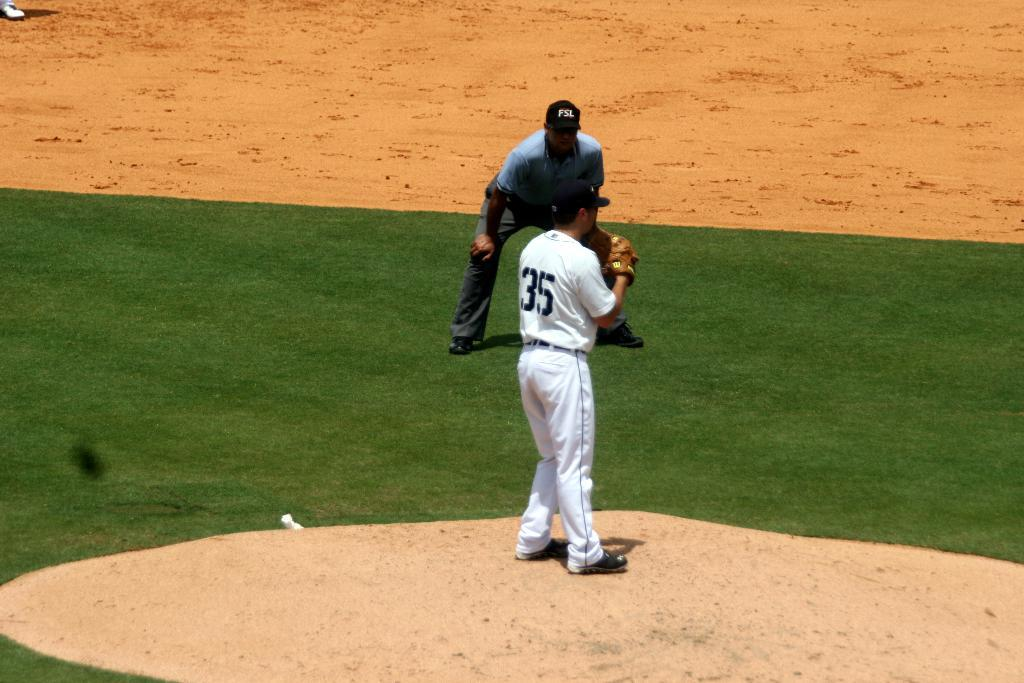Provide a one-sentence caption for the provided image. Baseball player number 35 stands on the pitchers mound ready to throw. 